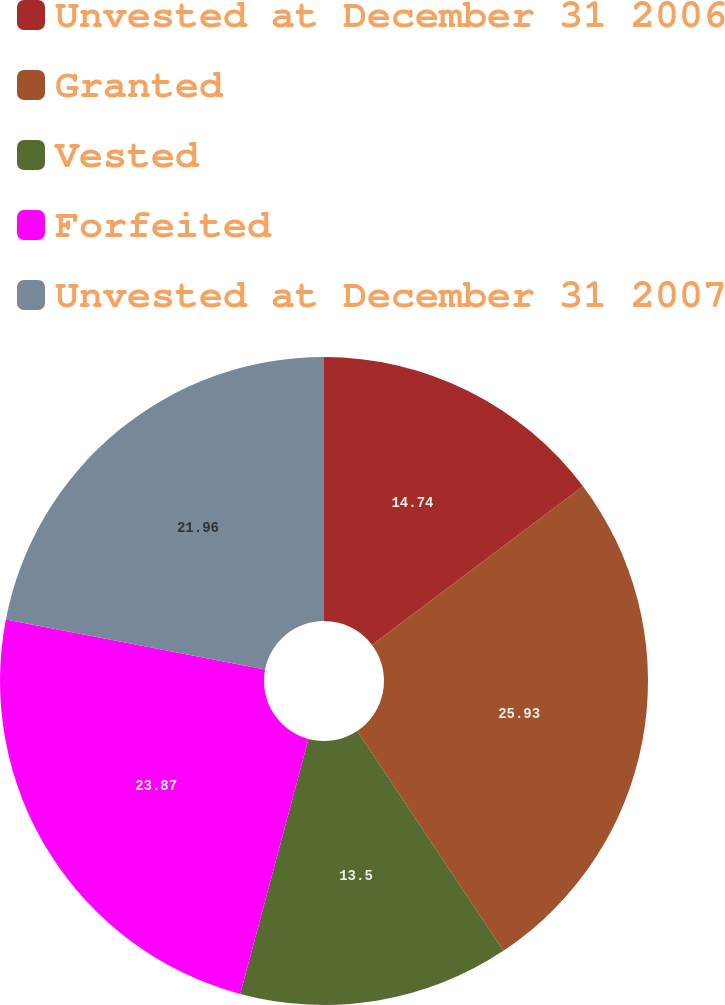Convert chart. <chart><loc_0><loc_0><loc_500><loc_500><pie_chart><fcel>Unvested at December 31 2006<fcel>Granted<fcel>Vested<fcel>Forfeited<fcel>Unvested at December 31 2007<nl><fcel>14.74%<fcel>25.92%<fcel>13.5%<fcel>23.87%<fcel>21.96%<nl></chart> 